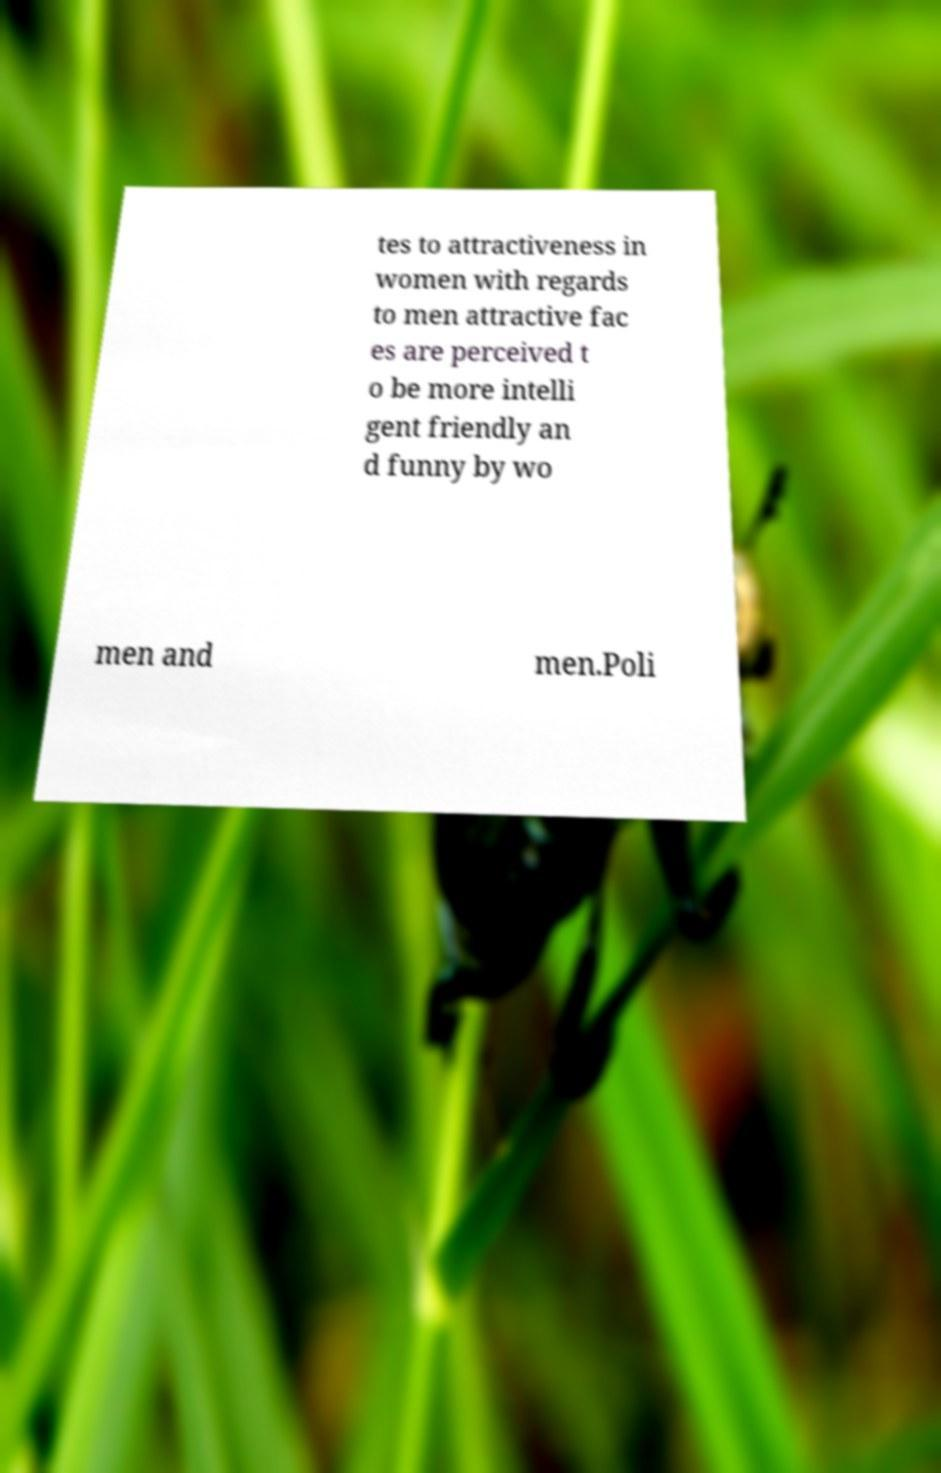Can you read and provide the text displayed in the image?This photo seems to have some interesting text. Can you extract and type it out for me? tes to attractiveness in women with regards to men attractive fac es are perceived t o be more intelli gent friendly an d funny by wo men and men.Poli 